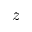Convert formula to latex. <formula><loc_0><loc_0><loc_500><loc_500>z</formula> 